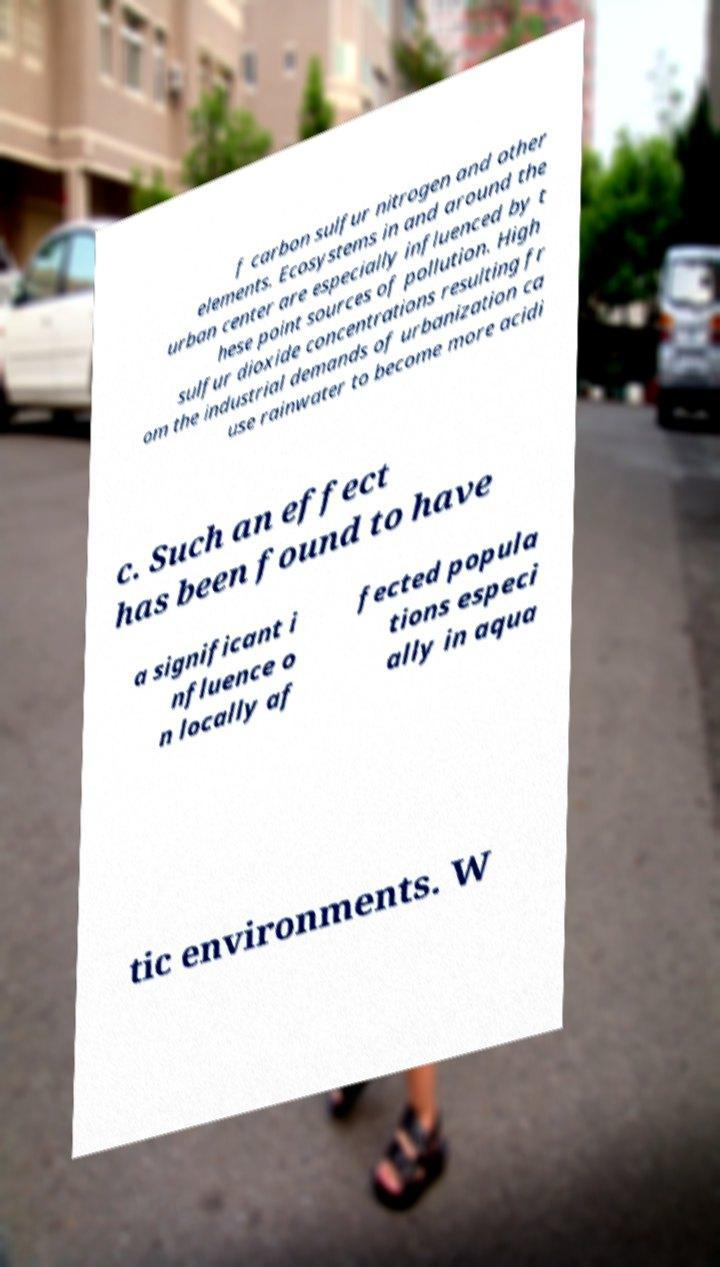There's text embedded in this image that I need extracted. Can you transcribe it verbatim? f carbon sulfur nitrogen and other elements. Ecosystems in and around the urban center are especially influenced by t hese point sources of pollution. High sulfur dioxide concentrations resulting fr om the industrial demands of urbanization ca use rainwater to become more acidi c. Such an effect has been found to have a significant i nfluence o n locally af fected popula tions especi ally in aqua tic environments. W 